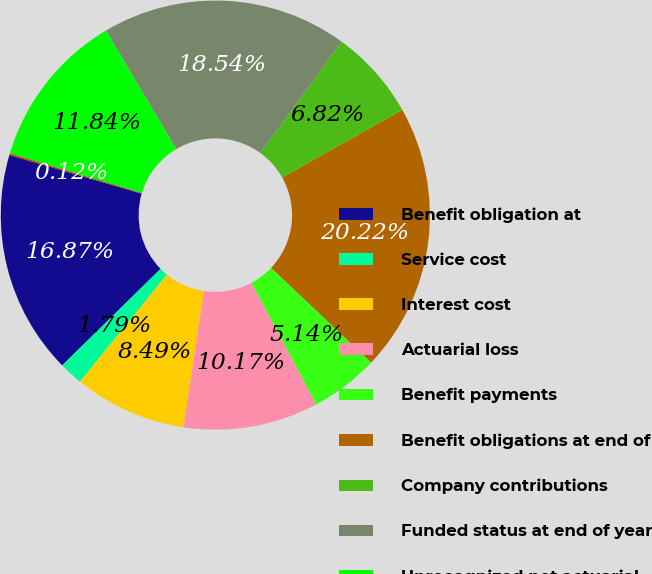Convert chart to OTSL. <chart><loc_0><loc_0><loc_500><loc_500><pie_chart><fcel>Benefit obligation at<fcel>Service cost<fcel>Interest cost<fcel>Actuarial loss<fcel>Benefit payments<fcel>Benefit obligations at end of<fcel>Company contributions<fcel>Funded status at end of year<fcel>Unrecognized net actuarial<fcel>Unrecognized transition/prior<nl><fcel>16.87%<fcel>1.79%<fcel>8.49%<fcel>10.17%<fcel>5.14%<fcel>20.22%<fcel>6.82%<fcel>18.54%<fcel>11.84%<fcel>0.12%<nl></chart> 